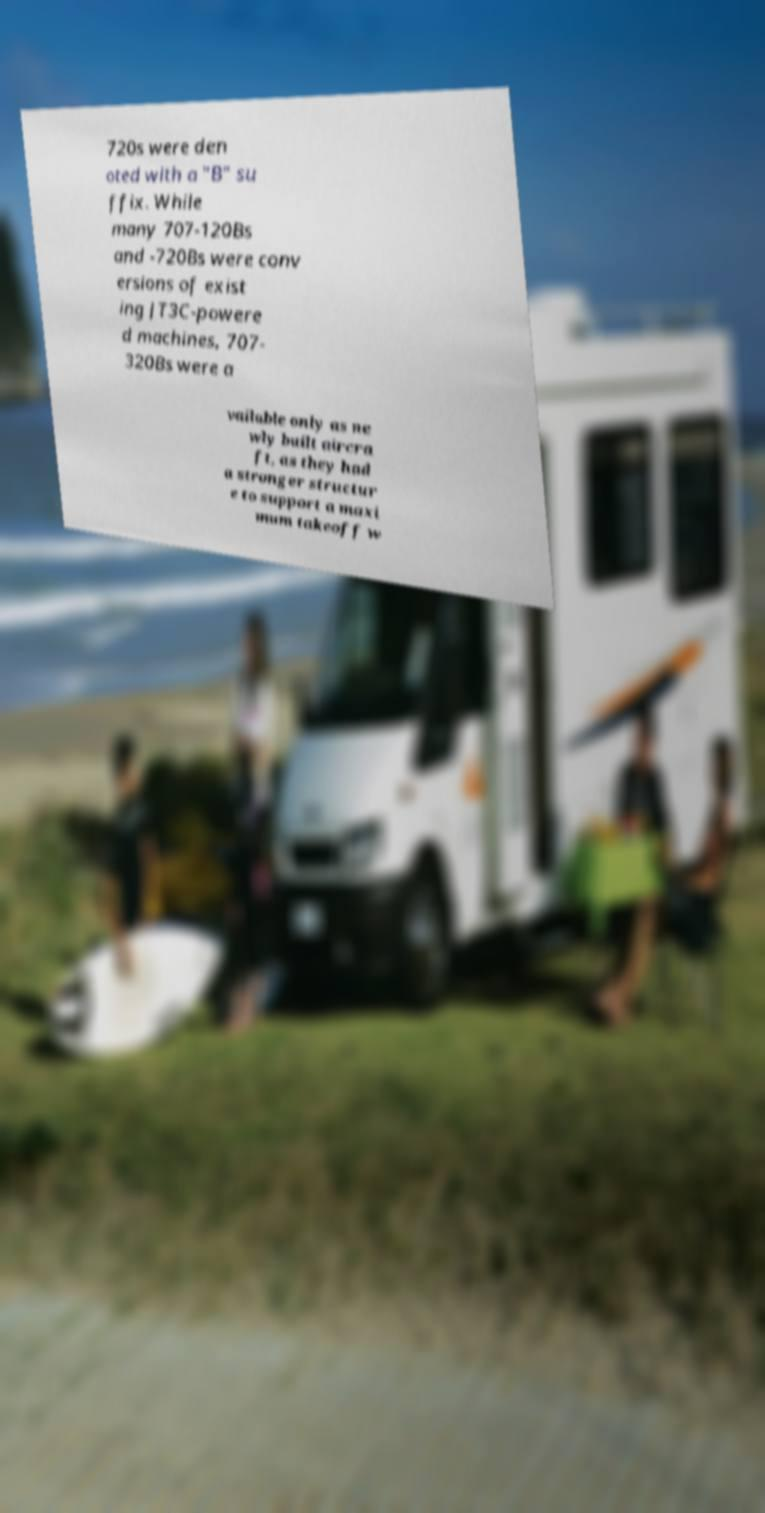There's text embedded in this image that I need extracted. Can you transcribe it verbatim? 720s were den oted with a "B" su ffix. While many 707-120Bs and -720Bs were conv ersions of exist ing JT3C-powere d machines, 707- 320Bs were a vailable only as ne wly built aircra ft, as they had a stronger structur e to support a maxi mum takeoff w 